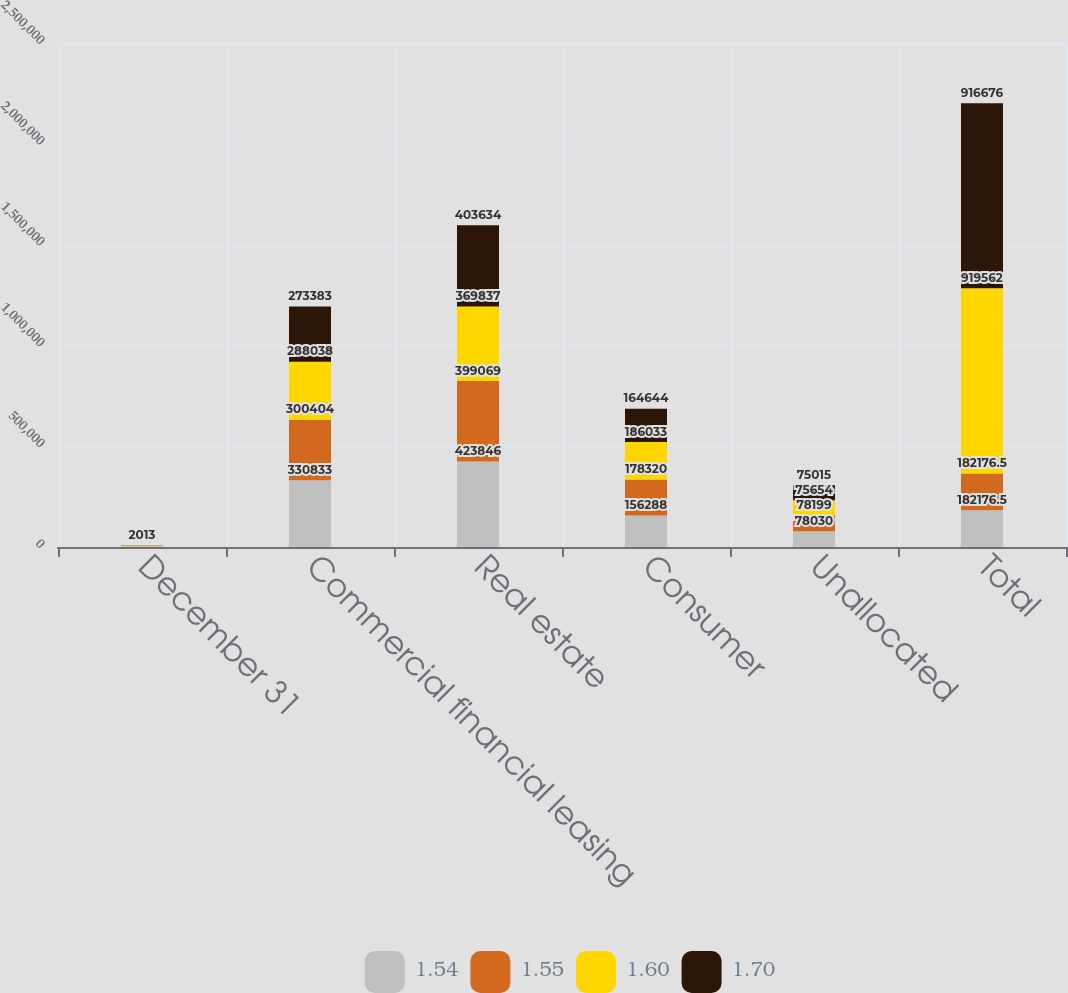Convert chart. <chart><loc_0><loc_0><loc_500><loc_500><stacked_bar_chart><ecel><fcel>December 31<fcel>Commercial financial leasing<fcel>Real estate<fcel>Consumer<fcel>Unallocated<fcel>Total<nl><fcel>1.54<fcel>2016<fcel>330833<fcel>423846<fcel>156288<fcel>78030<fcel>182176<nl><fcel>1.55<fcel>2015<fcel>300404<fcel>399069<fcel>178320<fcel>78199<fcel>182176<nl><fcel>1.6<fcel>2014<fcel>288038<fcel>369837<fcel>186033<fcel>75654<fcel>919562<nl><fcel>1.7<fcel>2013<fcel>273383<fcel>403634<fcel>164644<fcel>75015<fcel>916676<nl></chart> 